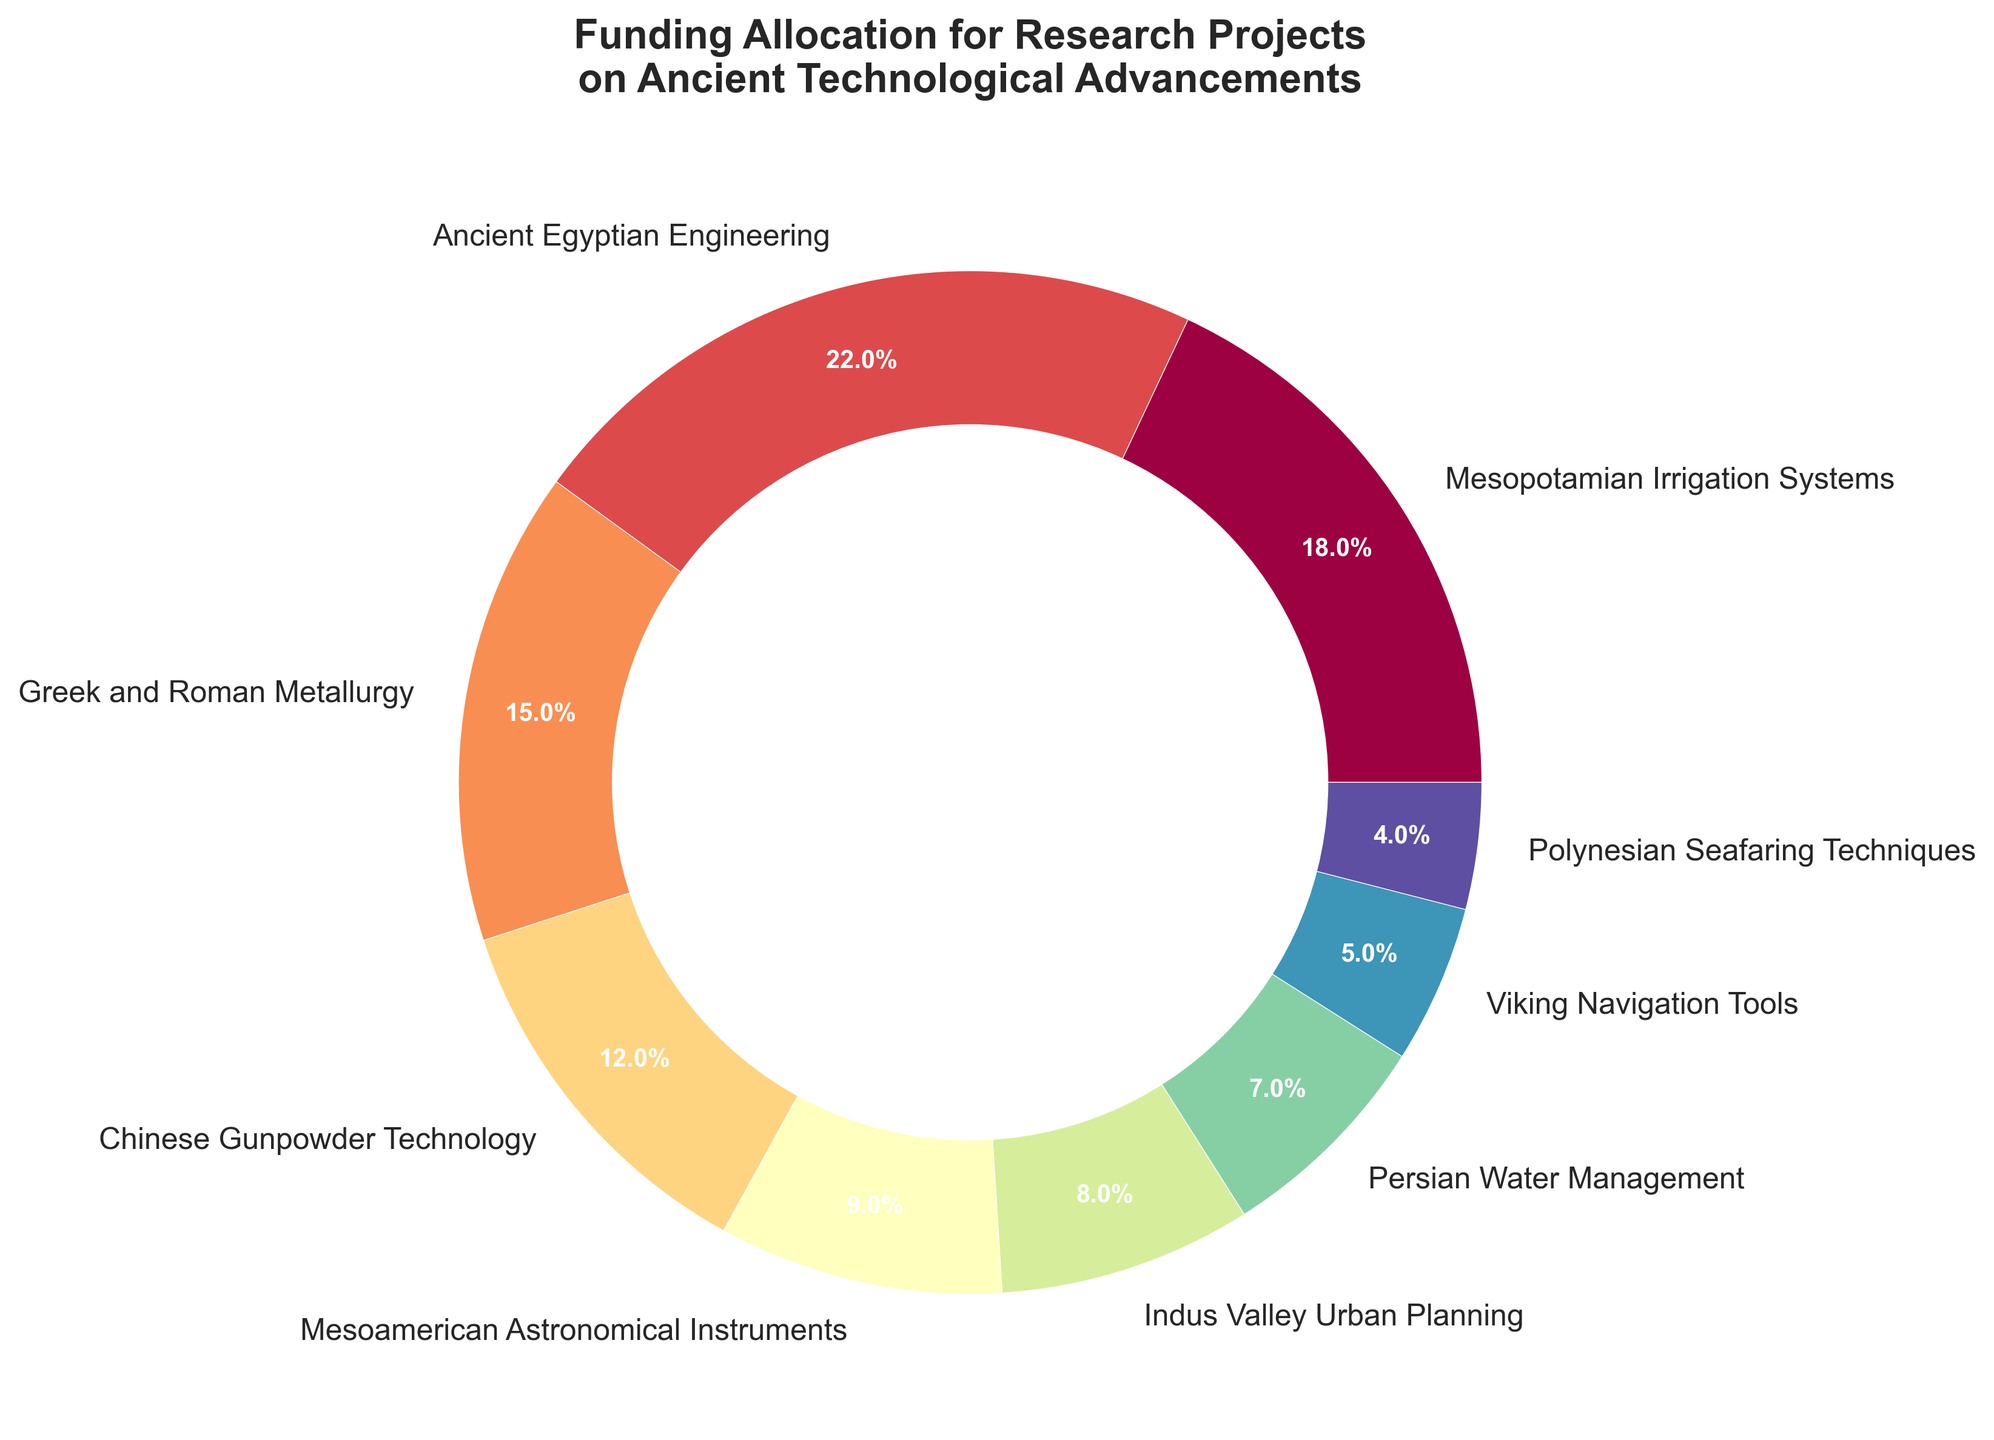Which research area received the highest funding allocation? From the pie chart, the segment with the highest percentage visible is "Ancient Egyptian Engineering," which allocated 22% of the total funding.
Answer: Ancient Egyptian Engineering Which two research areas received the same amount of funding? Observing the segments in the pie chart, there are no two research areas with identical funding allocations. Each segment has a unique percentage.
Answer: None What is the combined funding allocation of Mesopotamian Irrigation Systems and Greek and Roman Metallurgy research areas? From the chart, Mesopotamian Irrigation Systems has 18% and Greek and Roman Metallurgy has 15%. Therefore, adding these: 18% + 15% = 33%.
Answer: 33% How does the funding allocation for Chinese Gunpowder Technology compare to Mesoamerican Astronomical Instruments? According to the pie chart, Chinese Gunpowder Technology received 12% of the funding, while Mesoamerican Astronomical Instruments received 9%. Therefore, Chinese Gunpowder Technology received 3% more funding.
Answer: 3% more Which research area has the smallest funding allocation, and what percentage did it receive? By looking at the smallest segment in the pie chart, Polynesian Seafaring Techniques received the smallest funding allocation at 4%.
Answer: Polynesian Seafaring Techniques, 4% What is the difference in funding allocation between Indus Valley Urban Planning and Viking Navigation Tools? From the chart, Indus Valley Urban Planning has 8% funding and Viking Navigation Tools has 5%. The difference is 8% - 5% = 3%.
Answer: 3% Arrange the funding allocations from highest to lowest. The pie chart percentages from highest to lowest are: Ancient Egyptian Engineering (22%), Mesopotamian Irrigation Systems (18%), Greek and Roman Metallurgy (15%), Chinese Gunpowder Technology (12%), Mesoamerican Astronomical Instruments (9%), Indus Valley Urban Planning (8%), Persian Water Management (7%), Viking Navigation Tools (5%), Polynesian Seafaring Techniques (4%).
Answer: Ancient Egyptian Engineering > Mesopotamian Irrigation Systems > Greek and Roman Metallurgy > Chinese Gunpowder Technology > Mesoamerican Astronomical Instruments > Indus Valley Urban Planning > Persian Water Management > Viking Navigation Tools > Polynesian Seafaring Techniques What is the total funding allocation for the research areas receiving less than 10% funding each? We sum the percentages of Mesoamerican Astronomical Instruments (9%), Indus Valley Urban Planning (8%), Persian Water Management (7%), Viking Navigation Tools (5%), and Polynesian Seafaring Techniques (4%). The total is 9% + 8% + 7% + 5% + 4% = 33%.
Answer: 33% How much more funding does Ancient Egyptian Engineering receive compared to Persian Water Management? The pie chart indicates Ancient Egyptian Engineering receives 22% funding and Persian Water Management receives 7%. The difference is 22% - 7% = 15%.
Answer: 15% What are the funding allocations for research areas focusing on water-related technologies, and what's their combined total? Mesopotamian Irrigation Systems (18%) and Persian Water Management (7%) are water-related. Their combined total is 18% + 7% = 25%.
Answer: 25% 